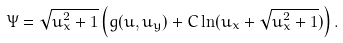Convert formula to latex. <formula><loc_0><loc_0><loc_500><loc_500>\Psi = \sqrt { u _ { x } ^ { 2 } + 1 } \left ( g ( u , u _ { y } ) + C \ln ( u _ { x } + \sqrt { u _ { x } ^ { 2 } + 1 } ) \right ) .</formula> 